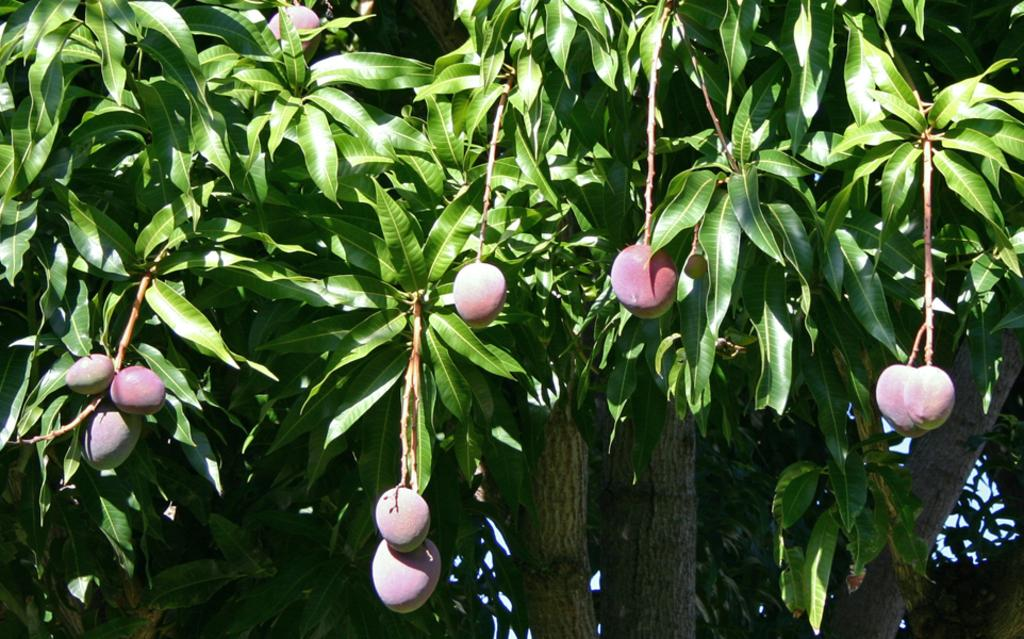What is present in the image? There is a tree in the image. Can you describe the tree in more detail? The tree has branches. What can be found on the tree? There are mangoes on the tree. What type of winter clothing is being worn by the mangoes in the image? There is no winter clothing present in the image, as it features a tree with mangoes and no people or animals wearing clothing. 